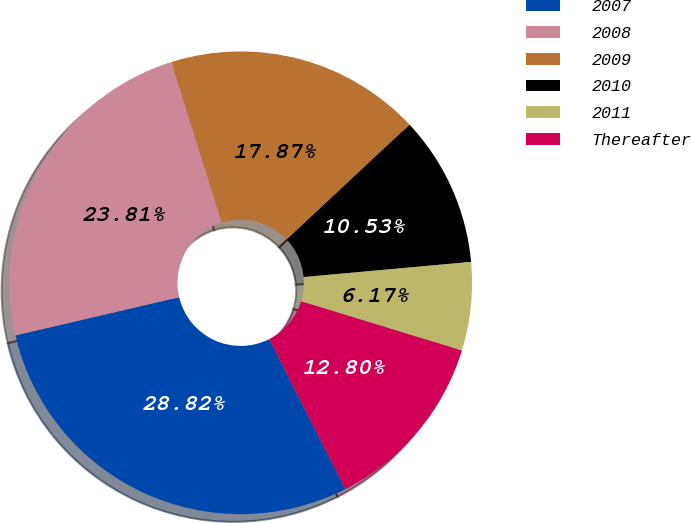Convert chart. <chart><loc_0><loc_0><loc_500><loc_500><pie_chart><fcel>2007<fcel>2008<fcel>2009<fcel>2010<fcel>2011<fcel>Thereafter<nl><fcel>28.82%<fcel>23.81%<fcel>17.87%<fcel>10.53%<fcel>6.17%<fcel>12.8%<nl></chart> 